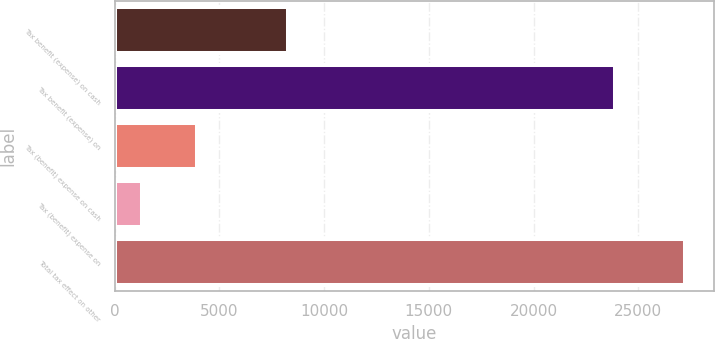Convert chart to OTSL. <chart><loc_0><loc_0><loc_500><loc_500><bar_chart><fcel>Tax benefit (expense) on cash<fcel>Tax benefit (expense) on<fcel>Tax (benefit) expense on cash<fcel>Tax (benefit) expense on<fcel>Total tax effect on other<nl><fcel>8259<fcel>23869<fcel>3917.9<fcel>1327<fcel>27236<nl></chart> 